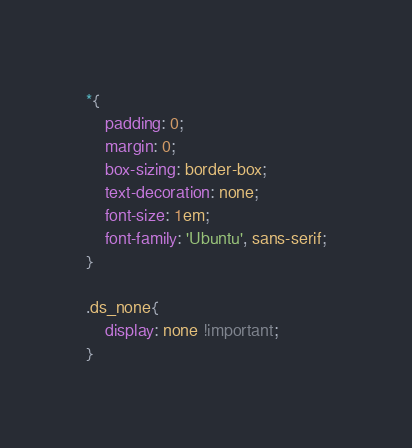<code> <loc_0><loc_0><loc_500><loc_500><_CSS_>*{
    padding: 0;
    margin: 0;
    box-sizing: border-box;
    text-decoration: none;
    font-size: 1em;
    font-family: 'Ubuntu', sans-serif;
}

.ds_none{
    display: none !important;
}


</code> 